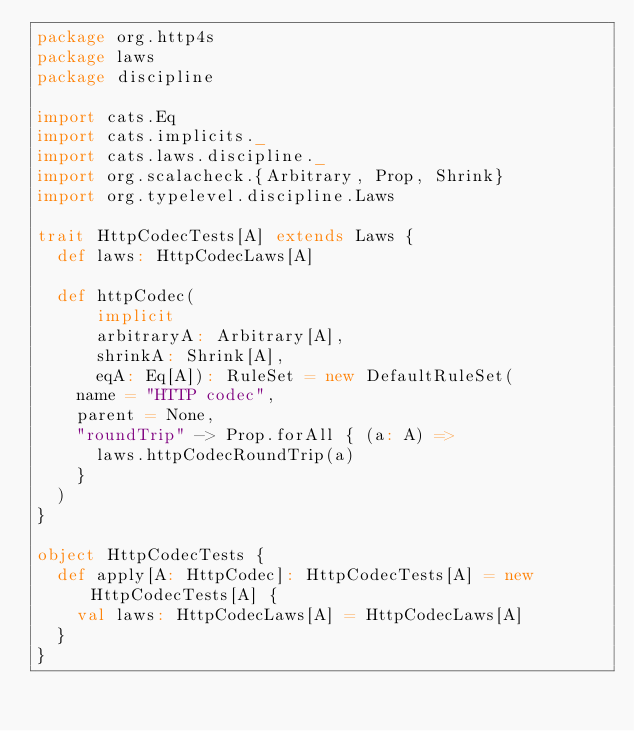<code> <loc_0><loc_0><loc_500><loc_500><_Scala_>package org.http4s
package laws
package discipline

import cats.Eq
import cats.implicits._
import cats.laws.discipline._
import org.scalacheck.{Arbitrary, Prop, Shrink}
import org.typelevel.discipline.Laws

trait HttpCodecTests[A] extends Laws {
  def laws: HttpCodecLaws[A]

  def httpCodec(
      implicit
      arbitraryA: Arbitrary[A],
      shrinkA: Shrink[A],
      eqA: Eq[A]): RuleSet = new DefaultRuleSet(
    name = "HTTP codec",
    parent = None,
    "roundTrip" -> Prop.forAll { (a: A) =>
      laws.httpCodecRoundTrip(a)
    }
  )
}

object HttpCodecTests {
  def apply[A: HttpCodec]: HttpCodecTests[A] = new HttpCodecTests[A] {
    val laws: HttpCodecLaws[A] = HttpCodecLaws[A]
  }
}
</code> 